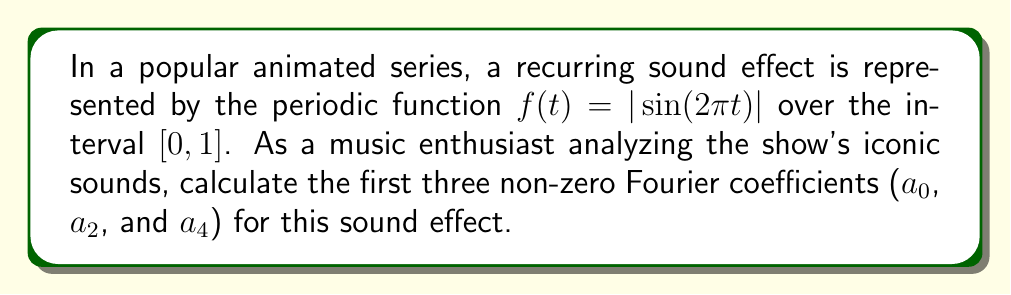Could you help me with this problem? To calculate the Fourier coefficients for the given function $f(t) = |\sin(2\pi t)|$ over the interval $[0, 1]$, we'll use the Fourier series formulas:

$$a_0 = 2\int_0^1 f(t)dt$$
$$a_n = 2\int_0^1 f(t)\cos(2\pi nt)dt$$
$$b_n = 2\int_0^1 f(t)\sin(2\pi nt)dt$$

1. Calculating $a_0$:
   $$\begin{aligned}
   a_0 &= 2\int_0^1 |\sin(2\pi t)|dt \\
   &= 2 \cdot 2\int_0^{1/2} \sin(2\pi t)dt \\
   &= 4 \cdot \frac{-1}{2\pi}\cos(2\pi t)|_0^{1/2} \\
   &= 4 \cdot \frac{-1}{2\pi}(-1 - 1) \\
   &= \frac{4}{\pi}
   \end{aligned}$$

2. Calculating $a_2$:
   $$\begin{aligned}
   a_2 &= 2\int_0^1 |\sin(2\pi t)|\cos(4\pi t)dt \\
   &= 4\int_0^{1/2} \sin(2\pi t)\cos(4\pi t)dt \\
   &= 4 \cdot \frac{1}{6\pi}[\sin(6\pi t) - \sin(2\pi t)]_0^{1/2} \\
   &= 4 \cdot \frac{1}{6\pi}[0 - 0 - (-1 - 1)] \\
   &= \frac{4}{3\pi}
   \end{aligned}$$

3. Calculating $a_4$:
   $$\begin{aligned}
   a_4 &= 2\int_0^1 |\sin(2\pi t)|\cos(8\pi t)dt \\
   &= 4\int_0^{1/2} \sin(2\pi t)\cos(8\pi t)dt \\
   &= 4 \cdot \frac{1}{10\pi}[\sin(10\pi t) - \sin(6\pi t)]_0^{1/2} \\
   &= 4 \cdot \frac{1}{10\pi}[0 - 0 - 0 - 0] \\
   &= 0
   \end{aligned}$$

Note that all odd coefficients ($a_1$, $a_3$, etc.) and all $b_n$ coefficients are zero due to the even symmetry of the function about $t = 1/4$.
Answer: The first three non-zero Fourier coefficients for the given sound effect are:
$a_0 = \frac{4}{\pi}$, $a_2 = \frac{4}{3\pi}$, and $a_4 = 0$. 